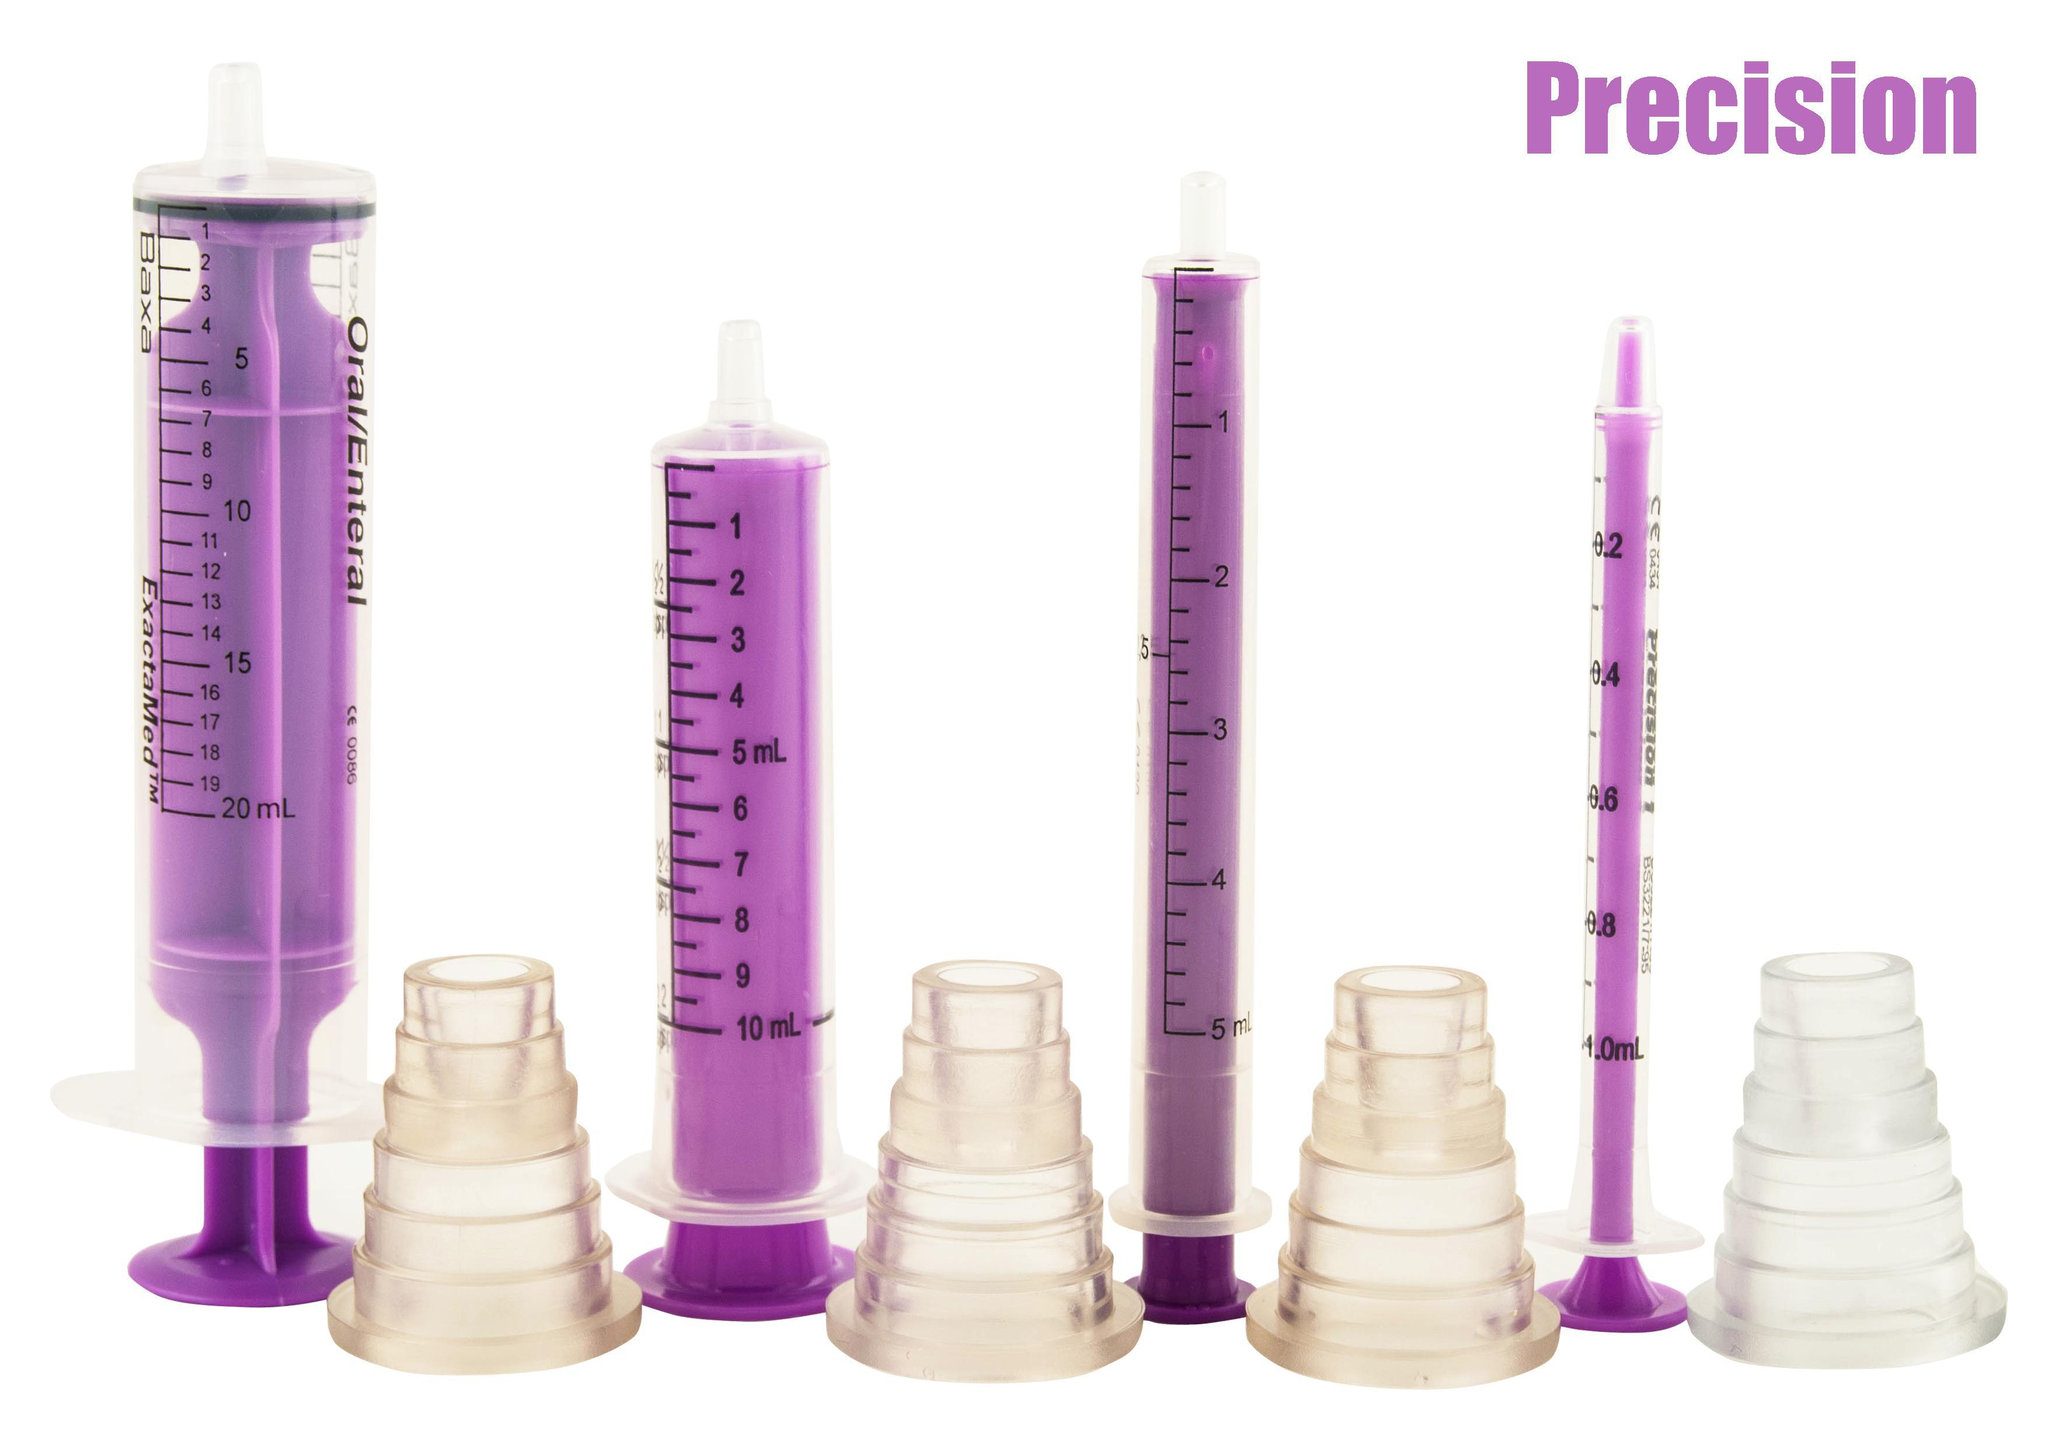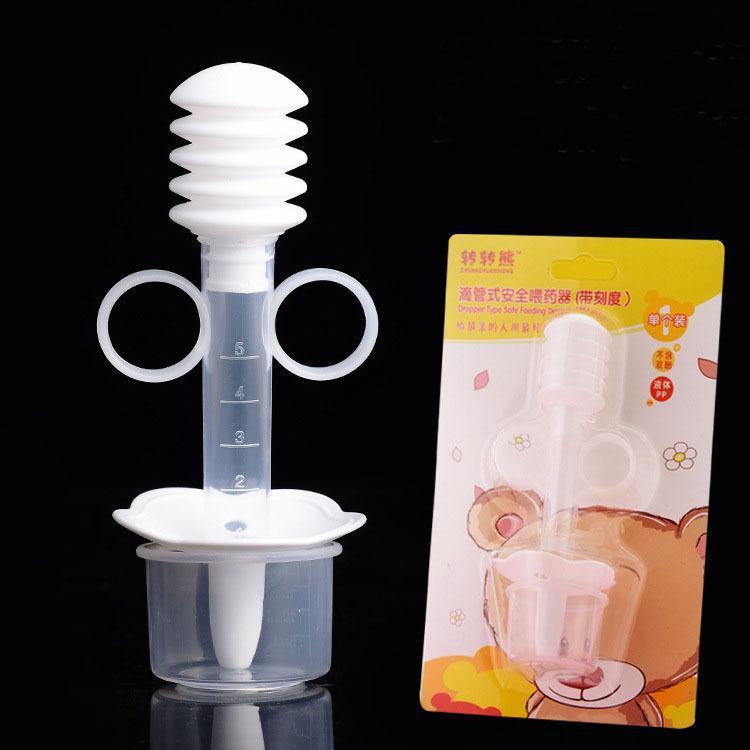The first image is the image on the left, the second image is the image on the right. Assess this claim about the two images: "There are exactly four syringes in one of the images.". Correct or not? Answer yes or no. Yes. 